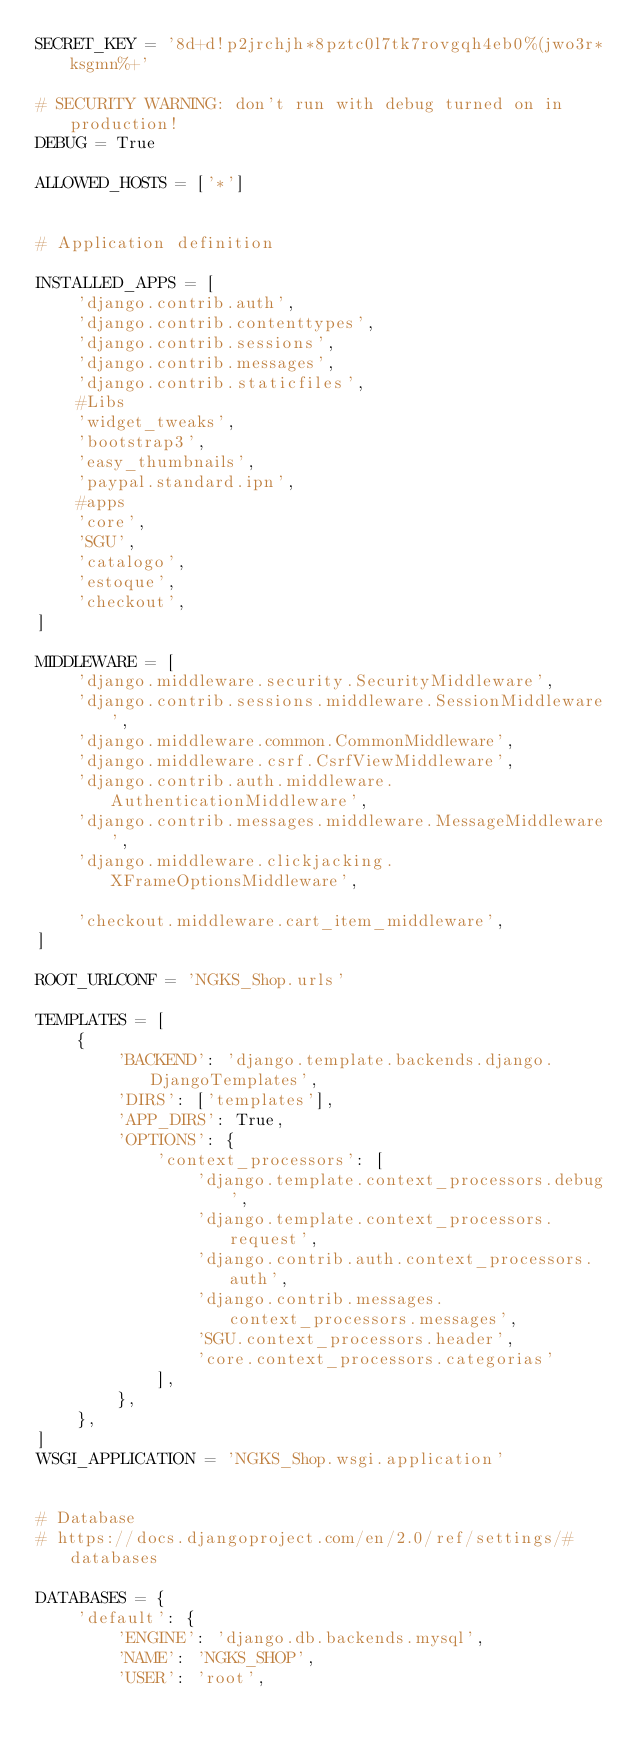<code> <loc_0><loc_0><loc_500><loc_500><_Python_>SECRET_KEY = '8d+d!p2jrchjh*8pztc0l7tk7rovgqh4eb0%(jwo3r*ksgmn%+'

# SECURITY WARNING: don't run with debug turned on in production!
DEBUG = True

ALLOWED_HOSTS = ['*']


# Application definition

INSTALLED_APPS = [
    'django.contrib.auth',
    'django.contrib.contenttypes',
    'django.contrib.sessions',
    'django.contrib.messages',
    'django.contrib.staticfiles',
    #Libs
    'widget_tweaks',
    'bootstrap3',
    'easy_thumbnails',
    'paypal.standard.ipn',
    #apps
    'core',
    'SGU',
    'catalogo',
    'estoque',
    'checkout',
]

MIDDLEWARE = [
    'django.middleware.security.SecurityMiddleware',
    'django.contrib.sessions.middleware.SessionMiddleware',
    'django.middleware.common.CommonMiddleware',
    'django.middleware.csrf.CsrfViewMiddleware',
    'django.contrib.auth.middleware.AuthenticationMiddleware',
    'django.contrib.messages.middleware.MessageMiddleware',
    'django.middleware.clickjacking.XFrameOptionsMiddleware',
    
    'checkout.middleware.cart_item_middleware',
]

ROOT_URLCONF = 'NGKS_Shop.urls'

TEMPLATES = [
    {
        'BACKEND': 'django.template.backends.django.DjangoTemplates',
        'DIRS': ['templates'],
        'APP_DIRS': True,
        'OPTIONS': {
            'context_processors': [
                'django.template.context_processors.debug',
                'django.template.context_processors.request',
                'django.contrib.auth.context_processors.auth',
                'django.contrib.messages.context_processors.messages',
                'SGU.context_processors.header',
                'core.context_processors.categorias'
            ],
        },
    },
]
WSGI_APPLICATION = 'NGKS_Shop.wsgi.application'


# Database
# https://docs.djangoproject.com/en/2.0/ref/settings/#databases

DATABASES = {
    'default': {
        'ENGINE': 'django.db.backends.mysql',
        'NAME': 'NGKS_SHOP',
        'USER': 'root',</code> 